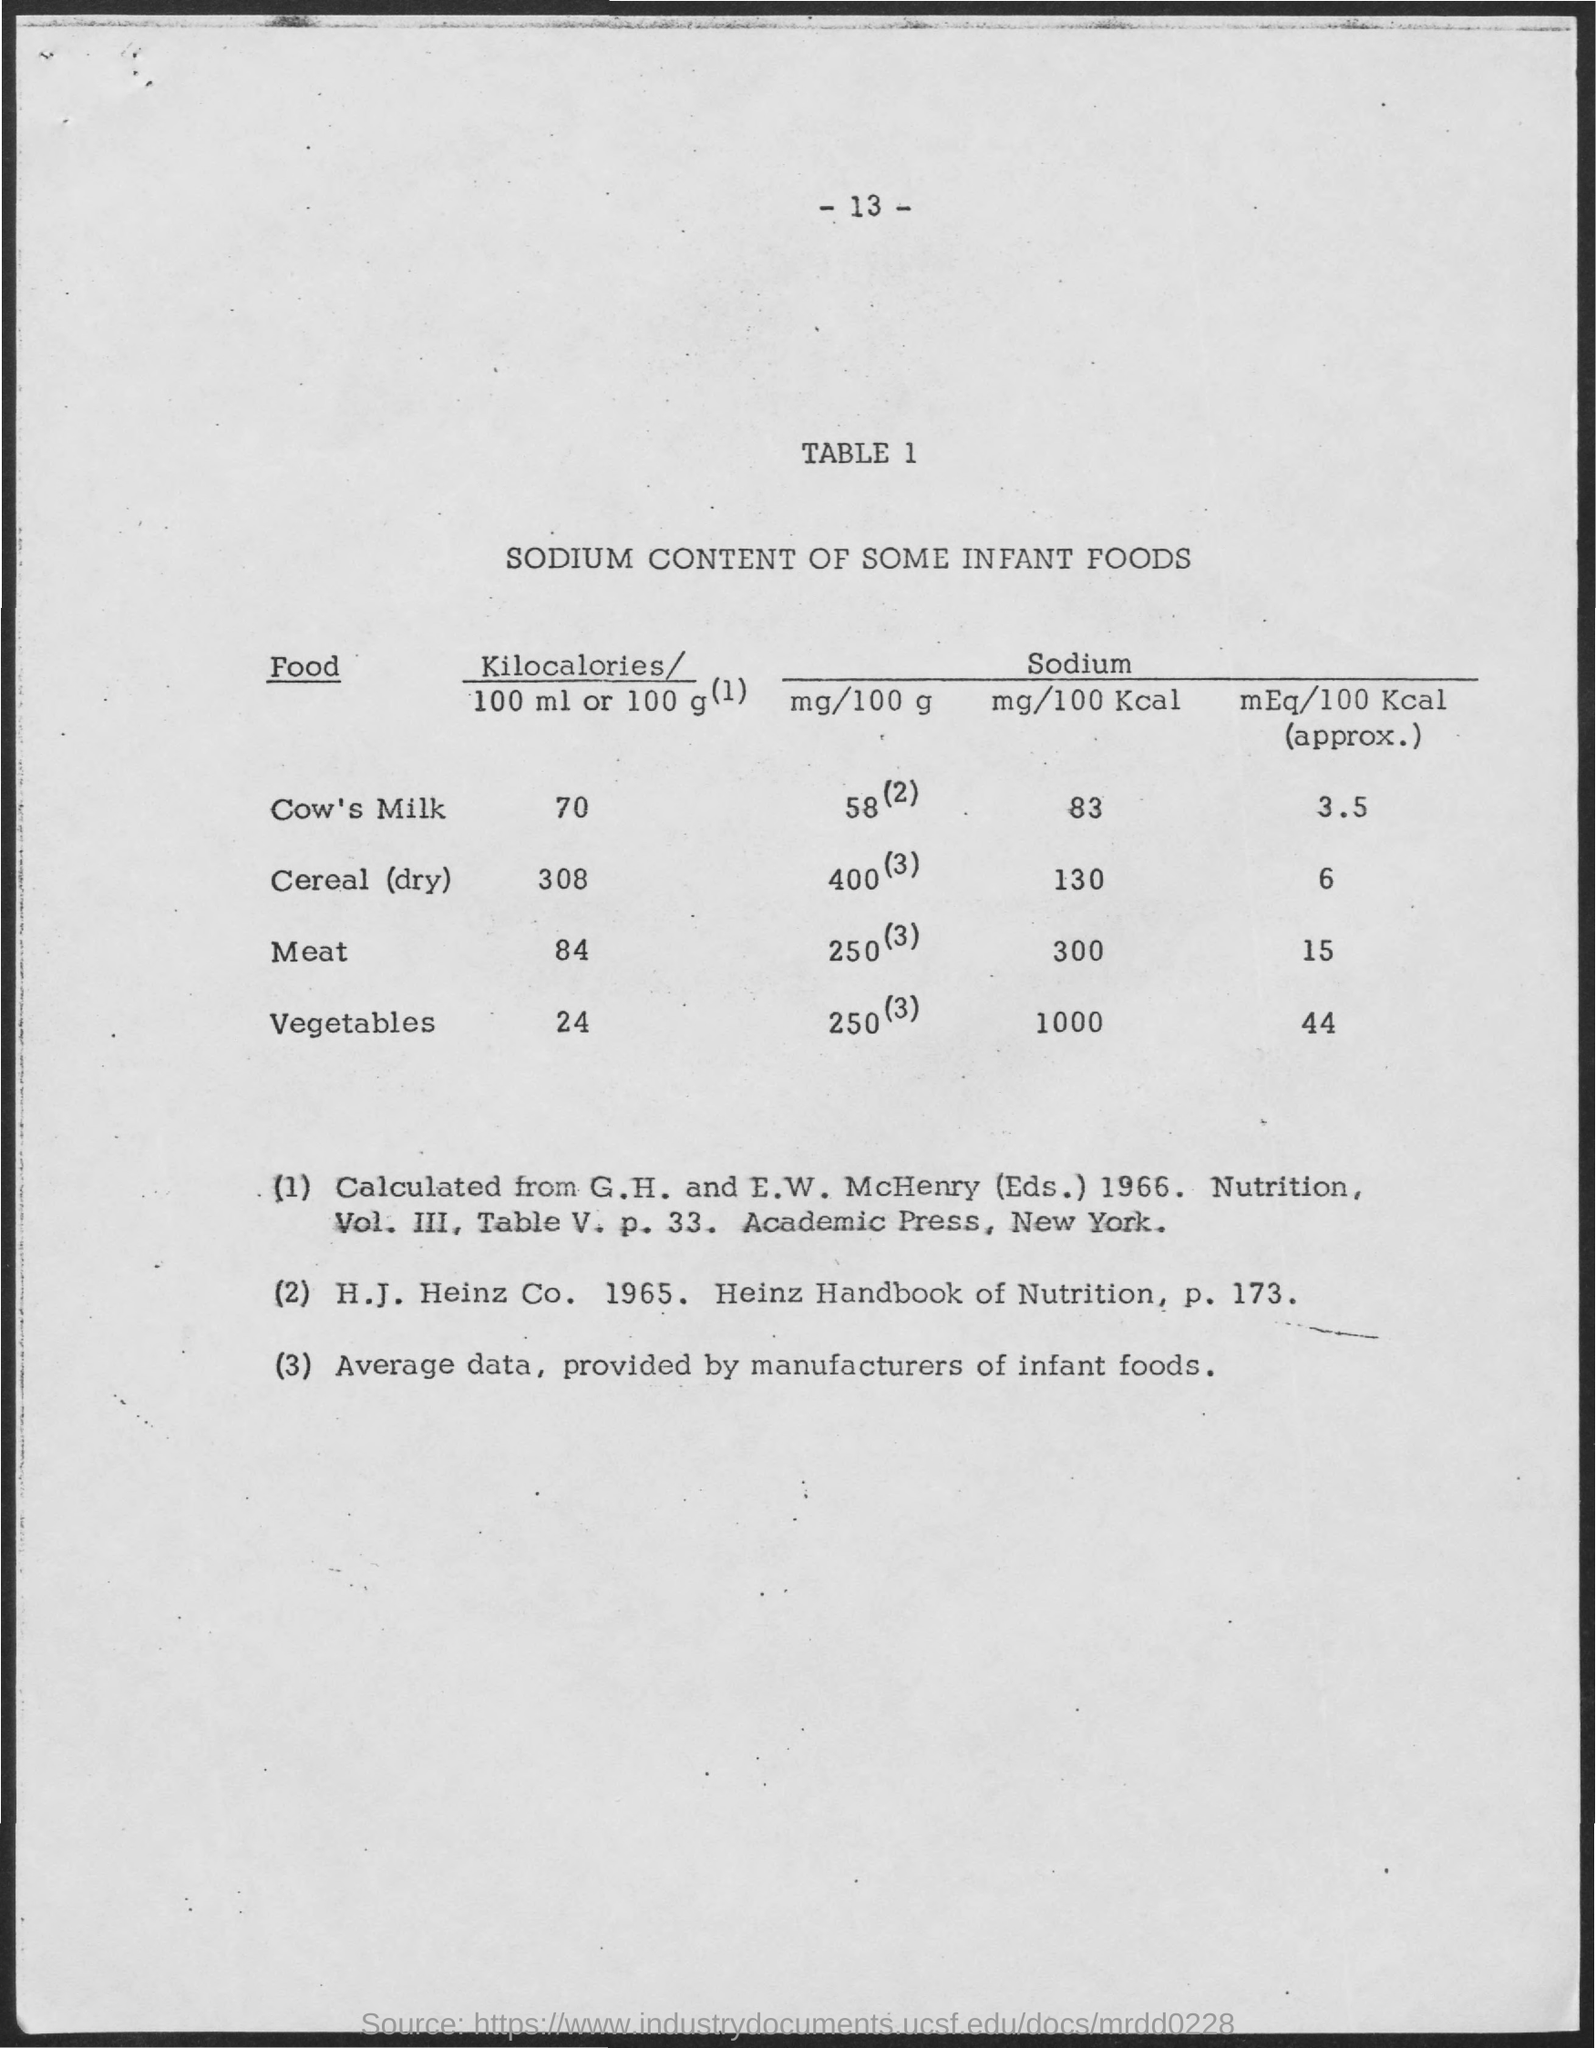What is the Sodium Content mg/100 Kcal for Cow's Milk?
Offer a very short reply. 83. What is the Sodium Content mg/100 Kcal for Cereal (dry)?
Provide a short and direct response. 130. What is the Sodium Content mg/100 Kcal for Meat?
Ensure brevity in your answer.  300. What is the Sodium Content mg/100 Kcal for Vegetables?
Give a very brief answer. 1000. What is the Sodium Content mEq/100 Kcal (approx.) for Cow's milk?
Offer a very short reply. 3.5. What is the Sodium Content mEq/100 Kcal (approx.) for Cereal (dry)?
Offer a terse response. 6. What is the Sodium Content mEq/100 Kcal (approx.) for Meat?
Provide a short and direct response. 15. What is the Sodium Content mEq/100 Kcal (approx.) for Vegetables?
Your answer should be very brief. 44. 